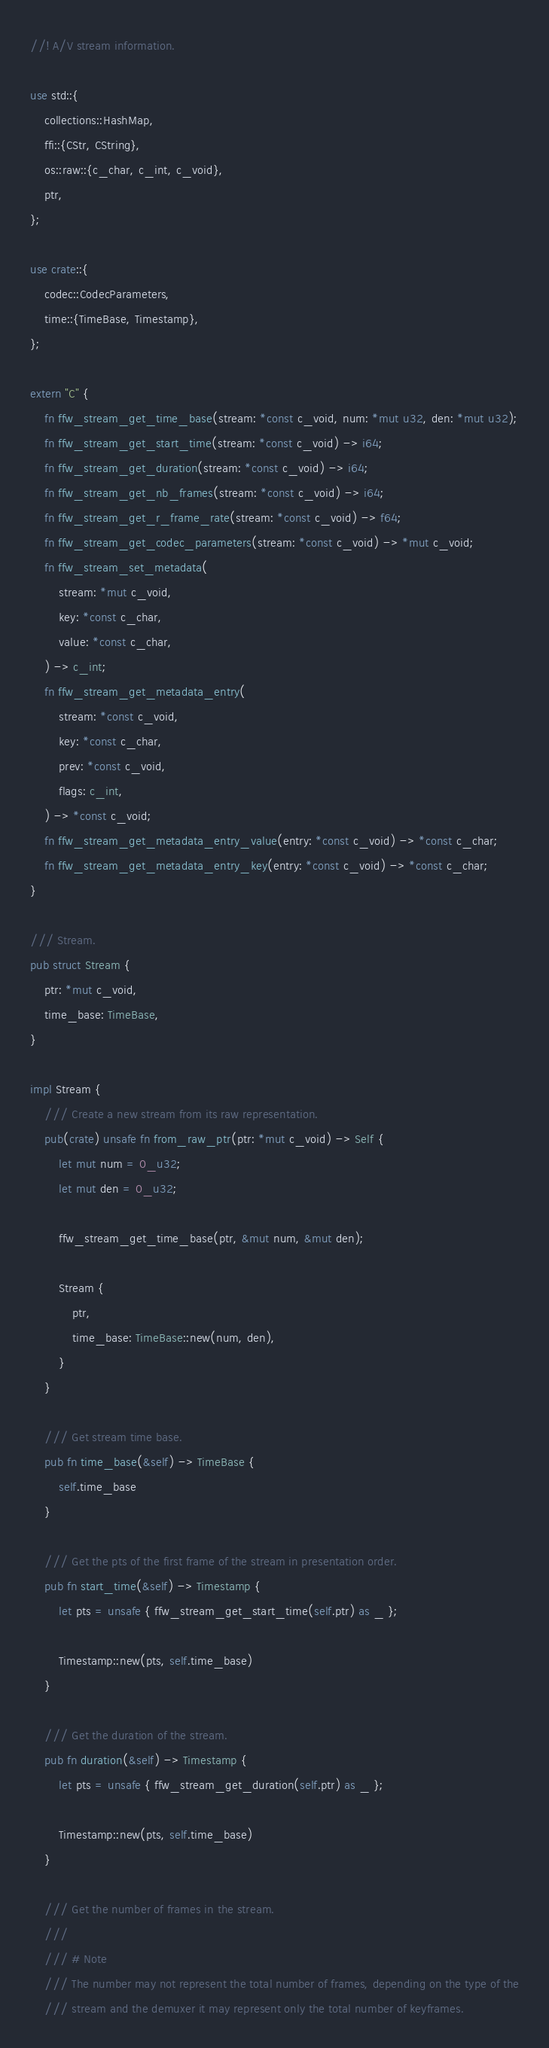<code> <loc_0><loc_0><loc_500><loc_500><_Rust_>//! A/V stream information.

use std::{
    collections::HashMap,
    ffi::{CStr, CString},
    os::raw::{c_char, c_int, c_void},
    ptr,
};

use crate::{
    codec::CodecParameters,
    time::{TimeBase, Timestamp},
};

extern "C" {
    fn ffw_stream_get_time_base(stream: *const c_void, num: *mut u32, den: *mut u32);
    fn ffw_stream_get_start_time(stream: *const c_void) -> i64;
    fn ffw_stream_get_duration(stream: *const c_void) -> i64;
    fn ffw_stream_get_nb_frames(stream: *const c_void) -> i64;
    fn ffw_stream_get_r_frame_rate(stream: *const c_void) -> f64;
    fn ffw_stream_get_codec_parameters(stream: *const c_void) -> *mut c_void;
    fn ffw_stream_set_metadata(
        stream: *mut c_void,
        key: *const c_char,
        value: *const c_char,
    ) -> c_int;
    fn ffw_stream_get_metadata_entry(
        stream: *const c_void,
        key: *const c_char,
        prev: *const c_void,
        flags: c_int,
    ) -> *const c_void;
    fn ffw_stream_get_metadata_entry_value(entry: *const c_void) -> *const c_char;
    fn ffw_stream_get_metadata_entry_key(entry: *const c_void) -> *const c_char;
}

/// Stream.
pub struct Stream {
    ptr: *mut c_void,
    time_base: TimeBase,
}

impl Stream {
    /// Create a new stream from its raw representation.
    pub(crate) unsafe fn from_raw_ptr(ptr: *mut c_void) -> Self {
        let mut num = 0_u32;
        let mut den = 0_u32;

        ffw_stream_get_time_base(ptr, &mut num, &mut den);

        Stream {
            ptr,
            time_base: TimeBase::new(num, den),
        }
    }

    /// Get stream time base.
    pub fn time_base(&self) -> TimeBase {
        self.time_base
    }

    /// Get the pts of the first frame of the stream in presentation order.
    pub fn start_time(&self) -> Timestamp {
        let pts = unsafe { ffw_stream_get_start_time(self.ptr) as _ };

        Timestamp::new(pts, self.time_base)
    }

    /// Get the duration of the stream.
    pub fn duration(&self) -> Timestamp {
        let pts = unsafe { ffw_stream_get_duration(self.ptr) as _ };

        Timestamp::new(pts, self.time_base)
    }

    /// Get the number of frames in the stream.
    ///
    /// # Note
    /// The number may not represent the total number of frames, depending on the type of the
    /// stream and the demuxer it may represent only the total number of keyframes.</code> 